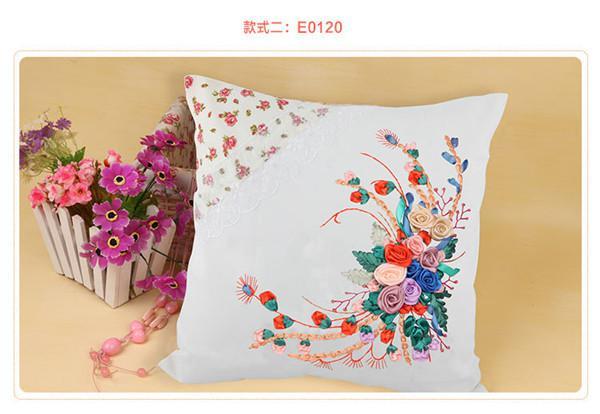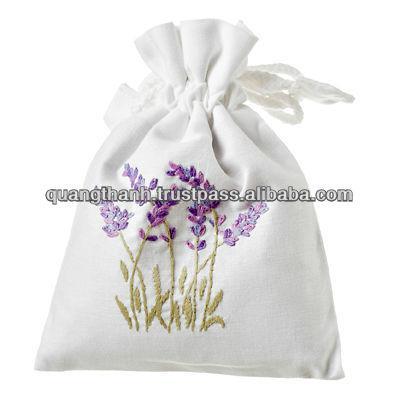The first image is the image on the left, the second image is the image on the right. Considering the images on both sides, is "At least one of the items contains a image of a lavender plant." valid? Answer yes or no. Yes. The first image is the image on the left, the second image is the image on the right. Analyze the images presented: Is the assertion "One image features one square pillow decorated with flowers, and the other image features at least one fabric item decorated with sprigs of lavender." valid? Answer yes or no. Yes. 